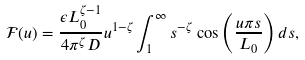Convert formula to latex. <formula><loc_0><loc_0><loc_500><loc_500>\mathcal { F } ( u ) = \frac { \epsilon L _ { 0 } ^ { \zeta - 1 } } { 4 \pi ^ { \zeta } D } u ^ { 1 - \zeta } \int _ { 1 } ^ { \infty } s ^ { - \zeta } \cos \left ( \frac { u \pi s } { L _ { 0 } } \right ) d s ,</formula> 